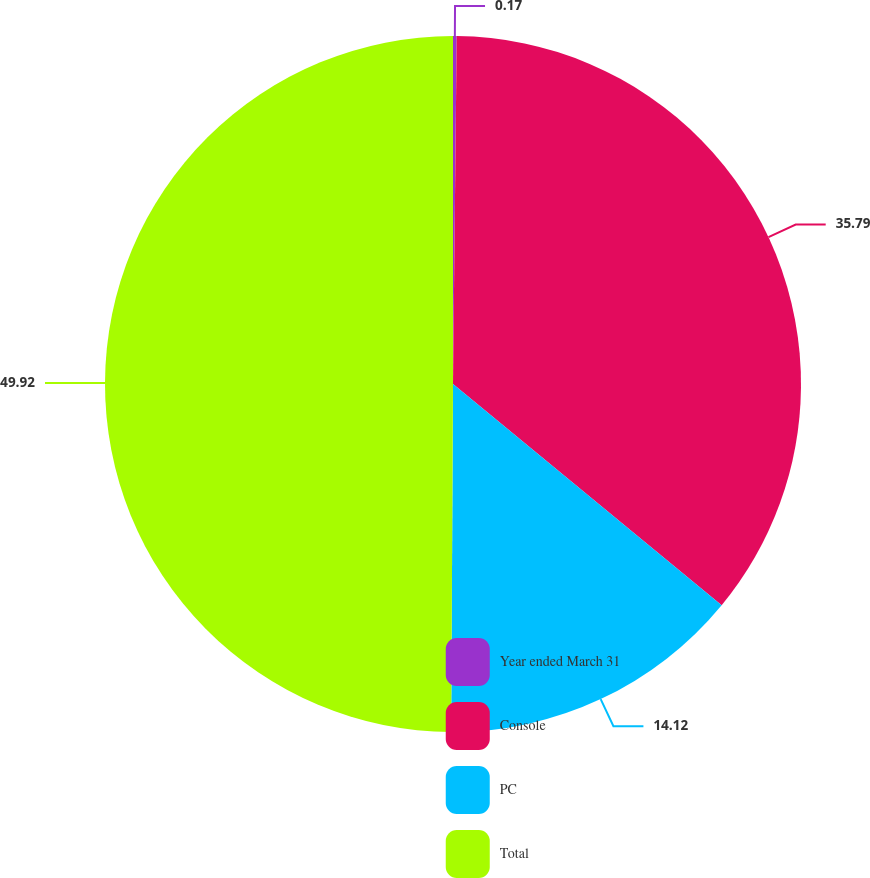Convert chart. <chart><loc_0><loc_0><loc_500><loc_500><pie_chart><fcel>Year ended March 31<fcel>Console<fcel>PC<fcel>Total<nl><fcel>0.17%<fcel>35.79%<fcel>14.12%<fcel>49.91%<nl></chart> 